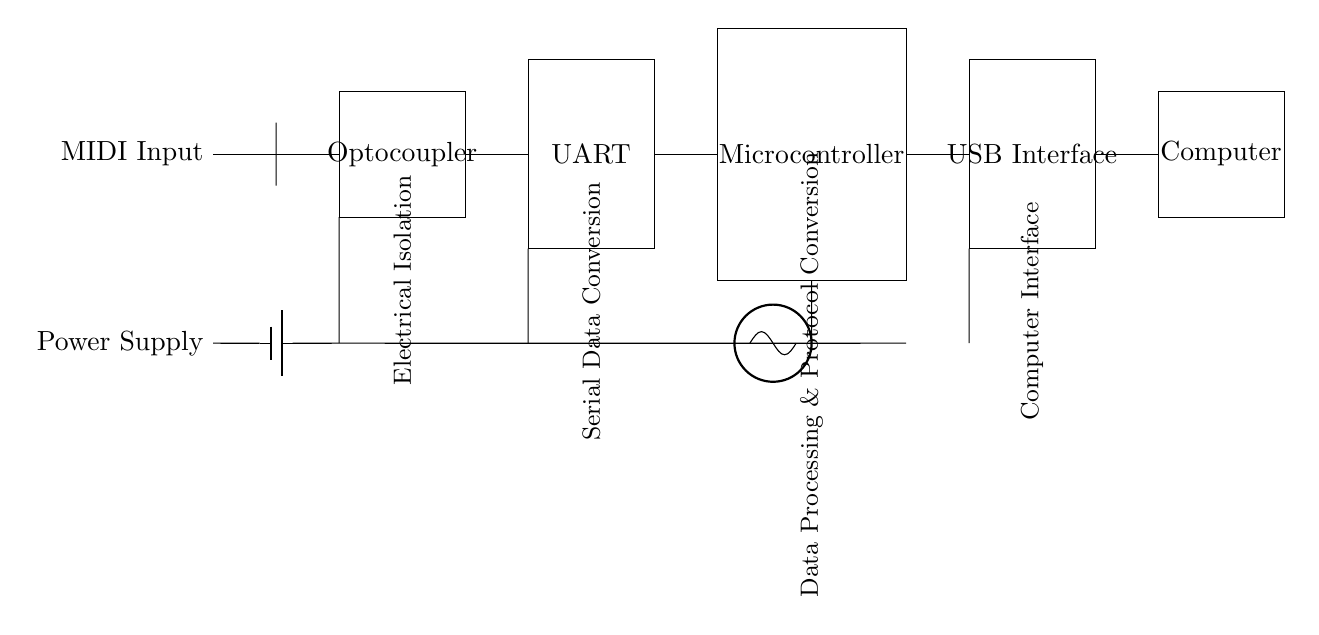What is the main function of the optocoupler in this circuit? The optocoupler provides electrical isolation between the MIDI input and the rest of the circuit, preventing any unwanted noise or signals from affecting the digital components.
Answer: Electrical Isolation What component converts MIDI signals into serial data? The UART (Universal Asynchronous Receiver-Transmitter) converts the MIDI signals into serial data suitable for processing by the microcontroller.
Answer: UART How many main components are connected after the MIDI input? There are three main components connected after the MIDI input: the optocoupler, the UART, and the microcontroller.
Answer: Three Which part of the circuit is responsible for data processing and protocol conversion? The microcontroller is responsible for data processing and protocol conversion in this circuit, as it interprets the incoming MIDI data and translates it for the USB interface.
Answer: Microcontroller What does the clock component provide for the circuit? The clock component provides timing signals necessary for synchronizing the data transmission and ensuring that all components communicate effectively at the correct intervals.
Answer: Timing signals 